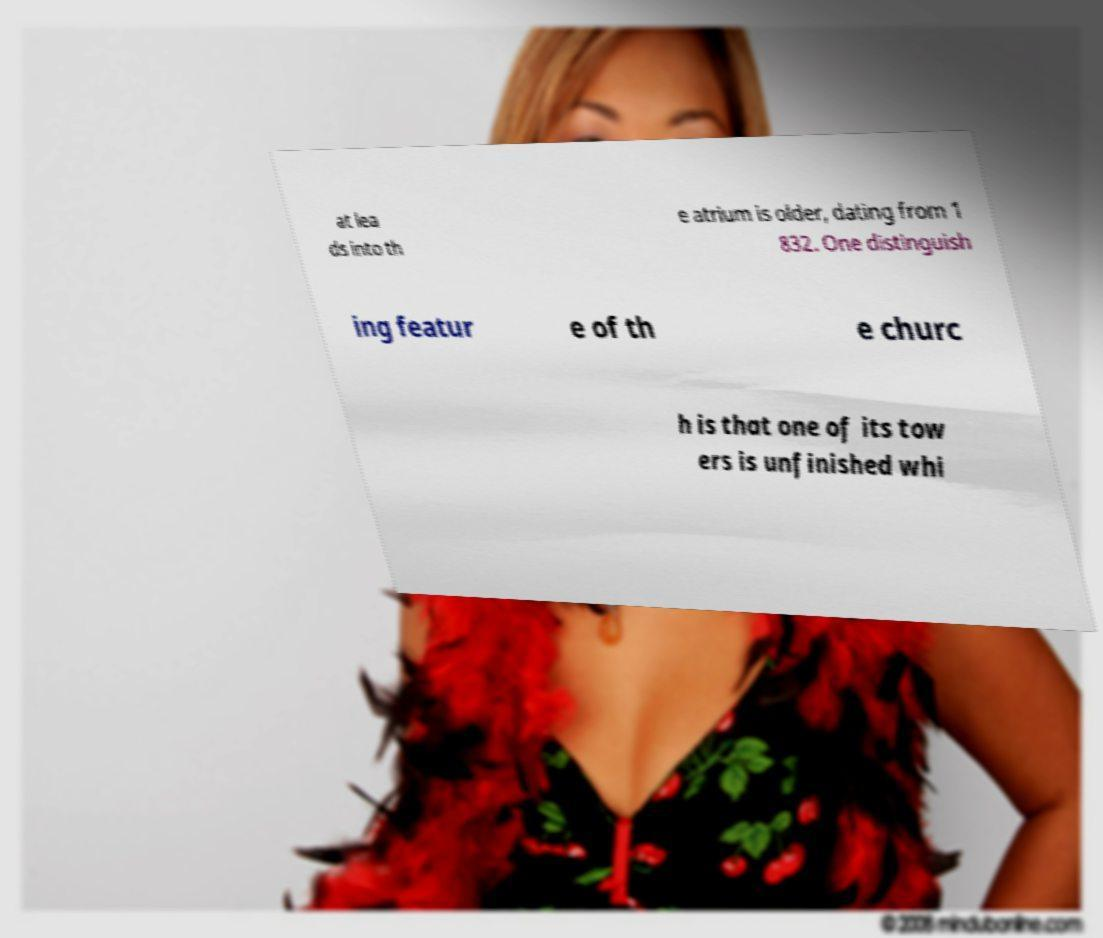Please read and relay the text visible in this image. What does it say? at lea ds into th e atrium is older, dating from 1 832. One distinguish ing featur e of th e churc h is that one of its tow ers is unfinished whi 